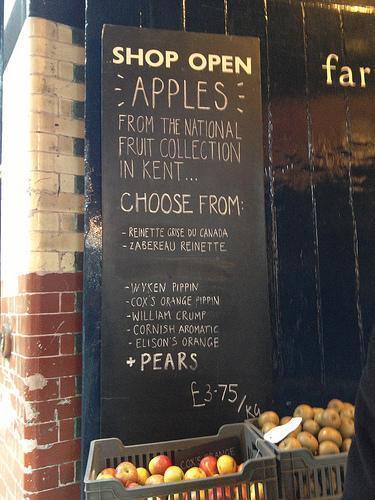How many bins are there?
Give a very brief answer. 2. How many crates have apples in them?
Give a very brief answer. 1. 